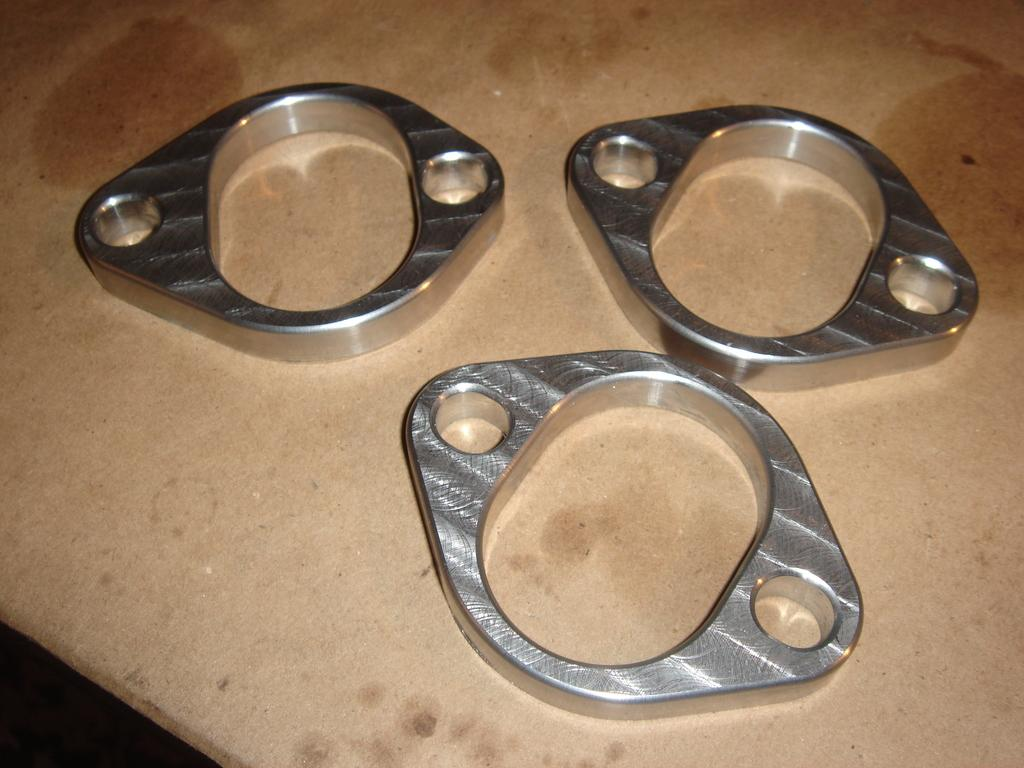What type of objects are present in the image? There are three metal objects in the image. What is the color of the surface on which the metal objects are placed? The metal objects are on a brown surface. Can you hear the metal objects laughing in the image? There is no sound or indication of laughter in the image; it is a still image of metal objects on a brown surface. 